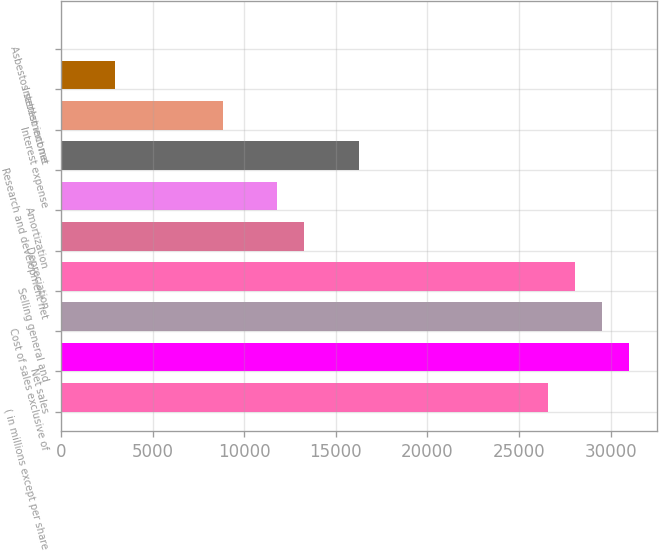<chart> <loc_0><loc_0><loc_500><loc_500><bar_chart><fcel>( in millions except per share<fcel>Net sales<fcel>Cost of sales exclusive of<fcel>Selling general and<fcel>Depreciation<fcel>Amortization<fcel>Research and development net<fcel>Interest expense<fcel>Interest income<fcel>Asbestos settlement net<nl><fcel>26569.2<fcel>30995.4<fcel>29520<fcel>28044.6<fcel>13290.6<fcel>11815.2<fcel>16241.4<fcel>8864.4<fcel>2962.8<fcel>12<nl></chart> 